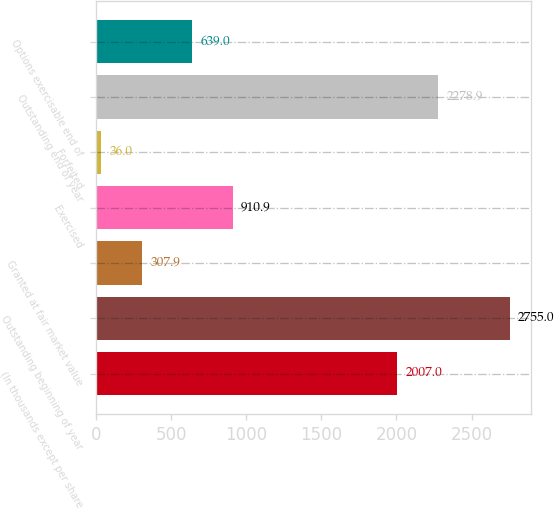<chart> <loc_0><loc_0><loc_500><loc_500><bar_chart><fcel>(In thousands except per share<fcel>Outstanding beginning of year<fcel>Granted at fair market value<fcel>Exercised<fcel>Forfeited<fcel>Outstanding end of year<fcel>Options exercisable end of<nl><fcel>2007<fcel>2755<fcel>307.9<fcel>910.9<fcel>36<fcel>2278.9<fcel>639<nl></chart> 